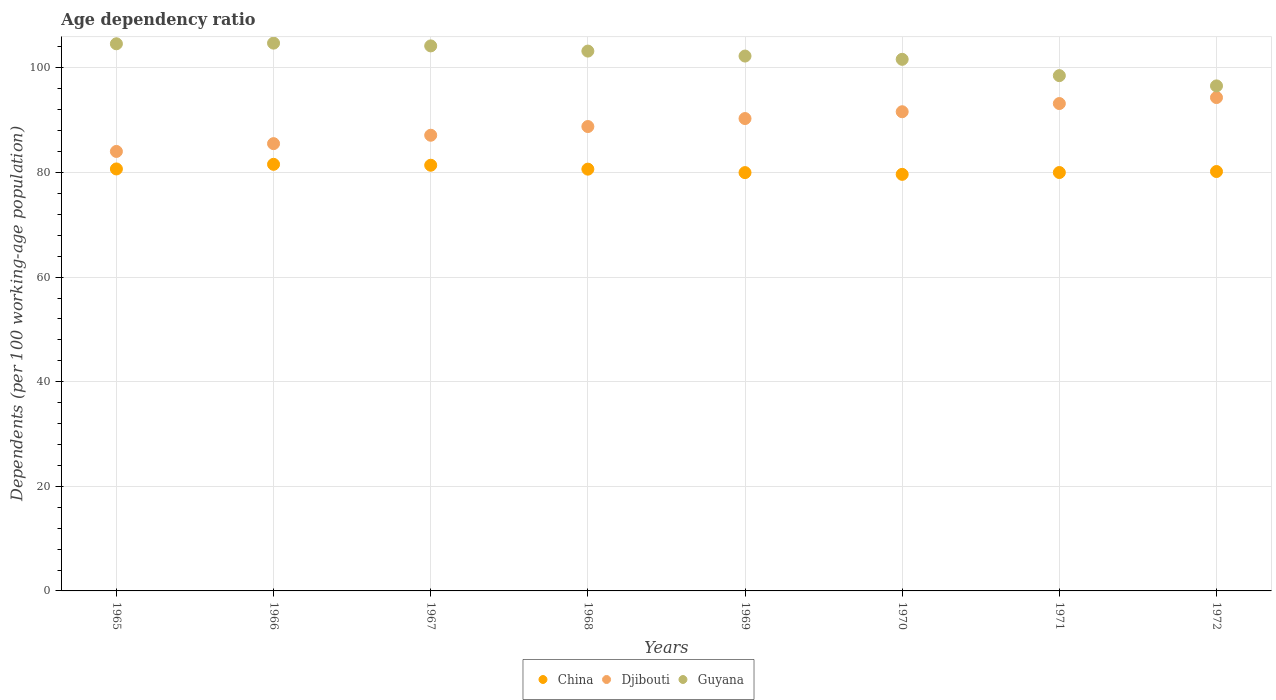What is the age dependency ratio in in Guyana in 1968?
Your answer should be compact. 103.22. Across all years, what is the maximum age dependency ratio in in Djibouti?
Keep it short and to the point. 94.33. Across all years, what is the minimum age dependency ratio in in Guyana?
Your answer should be compact. 96.56. In which year was the age dependency ratio in in Djibouti maximum?
Ensure brevity in your answer.  1972. In which year was the age dependency ratio in in Guyana minimum?
Provide a short and direct response. 1972. What is the total age dependency ratio in in China in the graph?
Your answer should be very brief. 644.09. What is the difference between the age dependency ratio in in Djibouti in 1967 and that in 1972?
Offer a terse response. -7.21. What is the difference between the age dependency ratio in in Guyana in 1967 and the age dependency ratio in in China in 1965?
Make the answer very short. 23.53. What is the average age dependency ratio in in China per year?
Provide a succinct answer. 80.51. In the year 1970, what is the difference between the age dependency ratio in in China and age dependency ratio in in Guyana?
Provide a succinct answer. -21.99. In how many years, is the age dependency ratio in in Djibouti greater than 96 %?
Offer a terse response. 0. What is the ratio of the age dependency ratio in in Djibouti in 1966 to that in 1972?
Offer a very short reply. 0.91. Is the age dependency ratio in in China in 1968 less than that in 1971?
Provide a succinct answer. No. Is the difference between the age dependency ratio in in China in 1969 and 1972 greater than the difference between the age dependency ratio in in Guyana in 1969 and 1972?
Ensure brevity in your answer.  No. What is the difference between the highest and the second highest age dependency ratio in in China?
Provide a short and direct response. 0.17. What is the difference between the highest and the lowest age dependency ratio in in Djibouti?
Keep it short and to the point. 10.3. In how many years, is the age dependency ratio in in China greater than the average age dependency ratio in in China taken over all years?
Your response must be concise. 4. Does the age dependency ratio in in China monotonically increase over the years?
Your answer should be very brief. No. How many dotlines are there?
Your response must be concise. 3. How many years are there in the graph?
Your response must be concise. 8. What is the difference between two consecutive major ticks on the Y-axis?
Your answer should be very brief. 20. What is the title of the graph?
Ensure brevity in your answer.  Age dependency ratio. Does "Venezuela" appear as one of the legend labels in the graph?
Make the answer very short. No. What is the label or title of the Y-axis?
Offer a very short reply. Dependents (per 100 working-age population). What is the Dependents (per 100 working-age population) in China in 1965?
Ensure brevity in your answer.  80.68. What is the Dependents (per 100 working-age population) of Djibouti in 1965?
Ensure brevity in your answer.  84.03. What is the Dependents (per 100 working-age population) of Guyana in 1965?
Offer a terse response. 104.61. What is the Dependents (per 100 working-age population) in China in 1966?
Provide a succinct answer. 81.57. What is the Dependents (per 100 working-age population) in Djibouti in 1966?
Keep it short and to the point. 85.52. What is the Dependents (per 100 working-age population) in Guyana in 1966?
Your response must be concise. 104.74. What is the Dependents (per 100 working-age population) of China in 1967?
Ensure brevity in your answer.  81.39. What is the Dependents (per 100 working-age population) in Djibouti in 1967?
Offer a terse response. 87.13. What is the Dependents (per 100 working-age population) in Guyana in 1967?
Provide a short and direct response. 104.21. What is the Dependents (per 100 working-age population) of China in 1968?
Give a very brief answer. 80.64. What is the Dependents (per 100 working-age population) of Djibouti in 1968?
Make the answer very short. 88.79. What is the Dependents (per 100 working-age population) of Guyana in 1968?
Provide a short and direct response. 103.22. What is the Dependents (per 100 working-age population) of China in 1969?
Your answer should be very brief. 79.98. What is the Dependents (per 100 working-age population) of Djibouti in 1969?
Your answer should be very brief. 90.32. What is the Dependents (per 100 working-age population) in Guyana in 1969?
Ensure brevity in your answer.  102.27. What is the Dependents (per 100 working-age population) in China in 1970?
Offer a very short reply. 79.65. What is the Dependents (per 100 working-age population) of Djibouti in 1970?
Your response must be concise. 91.62. What is the Dependents (per 100 working-age population) in Guyana in 1970?
Ensure brevity in your answer.  101.64. What is the Dependents (per 100 working-age population) of China in 1971?
Keep it short and to the point. 80. What is the Dependents (per 100 working-age population) in Djibouti in 1971?
Make the answer very short. 93.19. What is the Dependents (per 100 working-age population) of Guyana in 1971?
Your answer should be compact. 98.52. What is the Dependents (per 100 working-age population) of China in 1972?
Provide a succinct answer. 80.19. What is the Dependents (per 100 working-age population) of Djibouti in 1972?
Offer a terse response. 94.33. What is the Dependents (per 100 working-age population) in Guyana in 1972?
Provide a short and direct response. 96.56. Across all years, what is the maximum Dependents (per 100 working-age population) in China?
Offer a terse response. 81.57. Across all years, what is the maximum Dependents (per 100 working-age population) in Djibouti?
Your answer should be compact. 94.33. Across all years, what is the maximum Dependents (per 100 working-age population) of Guyana?
Offer a very short reply. 104.74. Across all years, what is the minimum Dependents (per 100 working-age population) of China?
Keep it short and to the point. 79.65. Across all years, what is the minimum Dependents (per 100 working-age population) in Djibouti?
Provide a short and direct response. 84.03. Across all years, what is the minimum Dependents (per 100 working-age population) of Guyana?
Offer a terse response. 96.56. What is the total Dependents (per 100 working-age population) in China in the graph?
Ensure brevity in your answer.  644.09. What is the total Dependents (per 100 working-age population) of Djibouti in the graph?
Offer a terse response. 714.92. What is the total Dependents (per 100 working-age population) of Guyana in the graph?
Your answer should be very brief. 815.76. What is the difference between the Dependents (per 100 working-age population) of China in 1965 and that in 1966?
Provide a short and direct response. -0.88. What is the difference between the Dependents (per 100 working-age population) in Djibouti in 1965 and that in 1966?
Your response must be concise. -1.49. What is the difference between the Dependents (per 100 working-age population) in Guyana in 1965 and that in 1966?
Keep it short and to the point. -0.12. What is the difference between the Dependents (per 100 working-age population) in China in 1965 and that in 1967?
Provide a short and direct response. -0.71. What is the difference between the Dependents (per 100 working-age population) in Djibouti in 1965 and that in 1967?
Keep it short and to the point. -3.1. What is the difference between the Dependents (per 100 working-age population) in Guyana in 1965 and that in 1967?
Keep it short and to the point. 0.41. What is the difference between the Dependents (per 100 working-age population) of China in 1965 and that in 1968?
Your answer should be compact. 0.04. What is the difference between the Dependents (per 100 working-age population) of Djibouti in 1965 and that in 1968?
Keep it short and to the point. -4.76. What is the difference between the Dependents (per 100 working-age population) in Guyana in 1965 and that in 1968?
Your answer should be compact. 1.4. What is the difference between the Dependents (per 100 working-age population) in China in 1965 and that in 1969?
Your answer should be very brief. 0.7. What is the difference between the Dependents (per 100 working-age population) of Djibouti in 1965 and that in 1969?
Your answer should be compact. -6.29. What is the difference between the Dependents (per 100 working-age population) of Guyana in 1965 and that in 1969?
Offer a terse response. 2.35. What is the difference between the Dependents (per 100 working-age population) of China in 1965 and that in 1970?
Provide a short and direct response. 1.03. What is the difference between the Dependents (per 100 working-age population) of Djibouti in 1965 and that in 1970?
Your answer should be very brief. -7.59. What is the difference between the Dependents (per 100 working-age population) in Guyana in 1965 and that in 1970?
Make the answer very short. 2.97. What is the difference between the Dependents (per 100 working-age population) of China in 1965 and that in 1971?
Give a very brief answer. 0.68. What is the difference between the Dependents (per 100 working-age population) of Djibouti in 1965 and that in 1971?
Keep it short and to the point. -9.16. What is the difference between the Dependents (per 100 working-age population) of Guyana in 1965 and that in 1971?
Your answer should be very brief. 6.09. What is the difference between the Dependents (per 100 working-age population) of China in 1965 and that in 1972?
Ensure brevity in your answer.  0.49. What is the difference between the Dependents (per 100 working-age population) of Djibouti in 1965 and that in 1972?
Ensure brevity in your answer.  -10.3. What is the difference between the Dependents (per 100 working-age population) of Guyana in 1965 and that in 1972?
Keep it short and to the point. 8.05. What is the difference between the Dependents (per 100 working-age population) of China in 1966 and that in 1967?
Offer a very short reply. 0.17. What is the difference between the Dependents (per 100 working-age population) in Djibouti in 1966 and that in 1967?
Your answer should be very brief. -1.61. What is the difference between the Dependents (per 100 working-age population) in Guyana in 1966 and that in 1967?
Keep it short and to the point. 0.53. What is the difference between the Dependents (per 100 working-age population) of China in 1966 and that in 1968?
Provide a succinct answer. 0.92. What is the difference between the Dependents (per 100 working-age population) of Djibouti in 1966 and that in 1968?
Make the answer very short. -3.27. What is the difference between the Dependents (per 100 working-age population) of Guyana in 1966 and that in 1968?
Provide a succinct answer. 1.52. What is the difference between the Dependents (per 100 working-age population) in China in 1966 and that in 1969?
Make the answer very short. 1.59. What is the difference between the Dependents (per 100 working-age population) in Djibouti in 1966 and that in 1969?
Your answer should be compact. -4.8. What is the difference between the Dependents (per 100 working-age population) of Guyana in 1966 and that in 1969?
Your answer should be very brief. 2.47. What is the difference between the Dependents (per 100 working-age population) in China in 1966 and that in 1970?
Provide a short and direct response. 1.92. What is the difference between the Dependents (per 100 working-age population) in Djibouti in 1966 and that in 1970?
Ensure brevity in your answer.  -6.1. What is the difference between the Dependents (per 100 working-age population) of Guyana in 1966 and that in 1970?
Provide a succinct answer. 3.09. What is the difference between the Dependents (per 100 working-age population) in China in 1966 and that in 1971?
Offer a very short reply. 1.57. What is the difference between the Dependents (per 100 working-age population) in Djibouti in 1966 and that in 1971?
Keep it short and to the point. -7.67. What is the difference between the Dependents (per 100 working-age population) in Guyana in 1966 and that in 1971?
Offer a terse response. 6.21. What is the difference between the Dependents (per 100 working-age population) of China in 1966 and that in 1972?
Provide a short and direct response. 1.38. What is the difference between the Dependents (per 100 working-age population) in Djibouti in 1966 and that in 1972?
Make the answer very short. -8.81. What is the difference between the Dependents (per 100 working-age population) in Guyana in 1966 and that in 1972?
Offer a terse response. 8.18. What is the difference between the Dependents (per 100 working-age population) of China in 1967 and that in 1968?
Offer a terse response. 0.75. What is the difference between the Dependents (per 100 working-age population) of Djibouti in 1967 and that in 1968?
Give a very brief answer. -1.66. What is the difference between the Dependents (per 100 working-age population) in China in 1967 and that in 1969?
Provide a short and direct response. 1.41. What is the difference between the Dependents (per 100 working-age population) of Djibouti in 1967 and that in 1969?
Your answer should be compact. -3.19. What is the difference between the Dependents (per 100 working-age population) of Guyana in 1967 and that in 1969?
Offer a very short reply. 1.94. What is the difference between the Dependents (per 100 working-age population) of China in 1967 and that in 1970?
Offer a very short reply. 1.74. What is the difference between the Dependents (per 100 working-age population) in Djibouti in 1967 and that in 1970?
Your response must be concise. -4.49. What is the difference between the Dependents (per 100 working-age population) of Guyana in 1967 and that in 1970?
Provide a succinct answer. 2.57. What is the difference between the Dependents (per 100 working-age population) in China in 1967 and that in 1971?
Offer a terse response. 1.39. What is the difference between the Dependents (per 100 working-age population) in Djibouti in 1967 and that in 1971?
Offer a terse response. -6.06. What is the difference between the Dependents (per 100 working-age population) of Guyana in 1967 and that in 1971?
Provide a succinct answer. 5.69. What is the difference between the Dependents (per 100 working-age population) in China in 1967 and that in 1972?
Give a very brief answer. 1.2. What is the difference between the Dependents (per 100 working-age population) of Djibouti in 1967 and that in 1972?
Your answer should be compact. -7.21. What is the difference between the Dependents (per 100 working-age population) in Guyana in 1967 and that in 1972?
Provide a short and direct response. 7.65. What is the difference between the Dependents (per 100 working-age population) of China in 1968 and that in 1969?
Offer a terse response. 0.66. What is the difference between the Dependents (per 100 working-age population) in Djibouti in 1968 and that in 1969?
Provide a short and direct response. -1.53. What is the difference between the Dependents (per 100 working-age population) in Guyana in 1968 and that in 1969?
Your response must be concise. 0.95. What is the difference between the Dependents (per 100 working-age population) of China in 1968 and that in 1970?
Provide a short and direct response. 0.99. What is the difference between the Dependents (per 100 working-age population) of Djibouti in 1968 and that in 1970?
Offer a very short reply. -2.83. What is the difference between the Dependents (per 100 working-age population) in Guyana in 1968 and that in 1970?
Provide a short and direct response. 1.57. What is the difference between the Dependents (per 100 working-age population) in China in 1968 and that in 1971?
Your answer should be compact. 0.64. What is the difference between the Dependents (per 100 working-age population) of Djibouti in 1968 and that in 1971?
Keep it short and to the point. -4.4. What is the difference between the Dependents (per 100 working-age population) of Guyana in 1968 and that in 1971?
Make the answer very short. 4.69. What is the difference between the Dependents (per 100 working-age population) of China in 1968 and that in 1972?
Your response must be concise. 0.45. What is the difference between the Dependents (per 100 working-age population) in Djibouti in 1968 and that in 1972?
Ensure brevity in your answer.  -5.54. What is the difference between the Dependents (per 100 working-age population) in Guyana in 1968 and that in 1972?
Your answer should be compact. 6.66. What is the difference between the Dependents (per 100 working-age population) in China in 1969 and that in 1970?
Make the answer very short. 0.33. What is the difference between the Dependents (per 100 working-age population) in Djibouti in 1969 and that in 1970?
Your answer should be very brief. -1.3. What is the difference between the Dependents (per 100 working-age population) in Guyana in 1969 and that in 1970?
Offer a very short reply. 0.62. What is the difference between the Dependents (per 100 working-age population) in China in 1969 and that in 1971?
Provide a short and direct response. -0.02. What is the difference between the Dependents (per 100 working-age population) in Djibouti in 1969 and that in 1971?
Your answer should be very brief. -2.87. What is the difference between the Dependents (per 100 working-age population) of Guyana in 1969 and that in 1971?
Offer a terse response. 3.74. What is the difference between the Dependents (per 100 working-age population) of China in 1969 and that in 1972?
Give a very brief answer. -0.21. What is the difference between the Dependents (per 100 working-age population) in Djibouti in 1969 and that in 1972?
Provide a short and direct response. -4.01. What is the difference between the Dependents (per 100 working-age population) of Guyana in 1969 and that in 1972?
Ensure brevity in your answer.  5.71. What is the difference between the Dependents (per 100 working-age population) in China in 1970 and that in 1971?
Offer a terse response. -0.35. What is the difference between the Dependents (per 100 working-age population) of Djibouti in 1970 and that in 1971?
Your answer should be compact. -1.57. What is the difference between the Dependents (per 100 working-age population) in Guyana in 1970 and that in 1971?
Give a very brief answer. 3.12. What is the difference between the Dependents (per 100 working-age population) in China in 1970 and that in 1972?
Provide a succinct answer. -0.54. What is the difference between the Dependents (per 100 working-age population) in Djibouti in 1970 and that in 1972?
Offer a very short reply. -2.71. What is the difference between the Dependents (per 100 working-age population) of Guyana in 1970 and that in 1972?
Provide a short and direct response. 5.08. What is the difference between the Dependents (per 100 working-age population) in China in 1971 and that in 1972?
Give a very brief answer. -0.19. What is the difference between the Dependents (per 100 working-age population) of Djibouti in 1971 and that in 1972?
Your answer should be very brief. -1.15. What is the difference between the Dependents (per 100 working-age population) in Guyana in 1971 and that in 1972?
Your response must be concise. 1.96. What is the difference between the Dependents (per 100 working-age population) of China in 1965 and the Dependents (per 100 working-age population) of Djibouti in 1966?
Ensure brevity in your answer.  -4.84. What is the difference between the Dependents (per 100 working-age population) in China in 1965 and the Dependents (per 100 working-age population) in Guyana in 1966?
Give a very brief answer. -24.05. What is the difference between the Dependents (per 100 working-age population) in Djibouti in 1965 and the Dependents (per 100 working-age population) in Guyana in 1966?
Your answer should be compact. -20.71. What is the difference between the Dependents (per 100 working-age population) of China in 1965 and the Dependents (per 100 working-age population) of Djibouti in 1967?
Your response must be concise. -6.44. What is the difference between the Dependents (per 100 working-age population) in China in 1965 and the Dependents (per 100 working-age population) in Guyana in 1967?
Keep it short and to the point. -23.53. What is the difference between the Dependents (per 100 working-age population) in Djibouti in 1965 and the Dependents (per 100 working-age population) in Guyana in 1967?
Ensure brevity in your answer.  -20.18. What is the difference between the Dependents (per 100 working-age population) of China in 1965 and the Dependents (per 100 working-age population) of Djibouti in 1968?
Your answer should be very brief. -8.11. What is the difference between the Dependents (per 100 working-age population) in China in 1965 and the Dependents (per 100 working-age population) in Guyana in 1968?
Give a very brief answer. -22.53. What is the difference between the Dependents (per 100 working-age population) in Djibouti in 1965 and the Dependents (per 100 working-age population) in Guyana in 1968?
Ensure brevity in your answer.  -19.19. What is the difference between the Dependents (per 100 working-age population) in China in 1965 and the Dependents (per 100 working-age population) in Djibouti in 1969?
Your answer should be compact. -9.64. What is the difference between the Dependents (per 100 working-age population) of China in 1965 and the Dependents (per 100 working-age population) of Guyana in 1969?
Offer a terse response. -21.58. What is the difference between the Dependents (per 100 working-age population) of Djibouti in 1965 and the Dependents (per 100 working-age population) of Guyana in 1969?
Your answer should be compact. -18.24. What is the difference between the Dependents (per 100 working-age population) in China in 1965 and the Dependents (per 100 working-age population) in Djibouti in 1970?
Ensure brevity in your answer.  -10.94. What is the difference between the Dependents (per 100 working-age population) of China in 1965 and the Dependents (per 100 working-age population) of Guyana in 1970?
Offer a very short reply. -20.96. What is the difference between the Dependents (per 100 working-age population) of Djibouti in 1965 and the Dependents (per 100 working-age population) of Guyana in 1970?
Provide a succinct answer. -17.61. What is the difference between the Dependents (per 100 working-age population) in China in 1965 and the Dependents (per 100 working-age population) in Djibouti in 1971?
Keep it short and to the point. -12.5. What is the difference between the Dependents (per 100 working-age population) of China in 1965 and the Dependents (per 100 working-age population) of Guyana in 1971?
Keep it short and to the point. -17.84. What is the difference between the Dependents (per 100 working-age population) of Djibouti in 1965 and the Dependents (per 100 working-age population) of Guyana in 1971?
Offer a very short reply. -14.49. What is the difference between the Dependents (per 100 working-age population) in China in 1965 and the Dependents (per 100 working-age population) in Djibouti in 1972?
Give a very brief answer. -13.65. What is the difference between the Dependents (per 100 working-age population) of China in 1965 and the Dependents (per 100 working-age population) of Guyana in 1972?
Offer a very short reply. -15.88. What is the difference between the Dependents (per 100 working-age population) of Djibouti in 1965 and the Dependents (per 100 working-age population) of Guyana in 1972?
Provide a succinct answer. -12.53. What is the difference between the Dependents (per 100 working-age population) in China in 1966 and the Dependents (per 100 working-age population) in Djibouti in 1967?
Ensure brevity in your answer.  -5.56. What is the difference between the Dependents (per 100 working-age population) in China in 1966 and the Dependents (per 100 working-age population) in Guyana in 1967?
Your answer should be very brief. -22.64. What is the difference between the Dependents (per 100 working-age population) in Djibouti in 1966 and the Dependents (per 100 working-age population) in Guyana in 1967?
Your answer should be compact. -18.69. What is the difference between the Dependents (per 100 working-age population) in China in 1966 and the Dependents (per 100 working-age population) in Djibouti in 1968?
Your response must be concise. -7.22. What is the difference between the Dependents (per 100 working-age population) in China in 1966 and the Dependents (per 100 working-age population) in Guyana in 1968?
Your answer should be compact. -21.65. What is the difference between the Dependents (per 100 working-age population) of Djibouti in 1966 and the Dependents (per 100 working-age population) of Guyana in 1968?
Ensure brevity in your answer.  -17.7. What is the difference between the Dependents (per 100 working-age population) in China in 1966 and the Dependents (per 100 working-age population) in Djibouti in 1969?
Keep it short and to the point. -8.75. What is the difference between the Dependents (per 100 working-age population) in China in 1966 and the Dependents (per 100 working-age population) in Guyana in 1969?
Your answer should be very brief. -20.7. What is the difference between the Dependents (per 100 working-age population) in Djibouti in 1966 and the Dependents (per 100 working-age population) in Guyana in 1969?
Give a very brief answer. -16.75. What is the difference between the Dependents (per 100 working-age population) of China in 1966 and the Dependents (per 100 working-age population) of Djibouti in 1970?
Give a very brief answer. -10.05. What is the difference between the Dependents (per 100 working-age population) in China in 1966 and the Dependents (per 100 working-age population) in Guyana in 1970?
Offer a very short reply. -20.08. What is the difference between the Dependents (per 100 working-age population) of Djibouti in 1966 and the Dependents (per 100 working-age population) of Guyana in 1970?
Offer a terse response. -16.12. What is the difference between the Dependents (per 100 working-age population) in China in 1966 and the Dependents (per 100 working-age population) in Djibouti in 1971?
Your response must be concise. -11.62. What is the difference between the Dependents (per 100 working-age population) in China in 1966 and the Dependents (per 100 working-age population) in Guyana in 1971?
Offer a very short reply. -16.96. What is the difference between the Dependents (per 100 working-age population) in Djibouti in 1966 and the Dependents (per 100 working-age population) in Guyana in 1971?
Your response must be concise. -13. What is the difference between the Dependents (per 100 working-age population) of China in 1966 and the Dependents (per 100 working-age population) of Djibouti in 1972?
Give a very brief answer. -12.77. What is the difference between the Dependents (per 100 working-age population) in China in 1966 and the Dependents (per 100 working-age population) in Guyana in 1972?
Your answer should be very brief. -15. What is the difference between the Dependents (per 100 working-age population) of Djibouti in 1966 and the Dependents (per 100 working-age population) of Guyana in 1972?
Your answer should be compact. -11.04. What is the difference between the Dependents (per 100 working-age population) of China in 1967 and the Dependents (per 100 working-age population) of Djibouti in 1968?
Make the answer very short. -7.4. What is the difference between the Dependents (per 100 working-age population) in China in 1967 and the Dependents (per 100 working-age population) in Guyana in 1968?
Offer a terse response. -21.83. What is the difference between the Dependents (per 100 working-age population) of Djibouti in 1967 and the Dependents (per 100 working-age population) of Guyana in 1968?
Give a very brief answer. -16.09. What is the difference between the Dependents (per 100 working-age population) in China in 1967 and the Dependents (per 100 working-age population) in Djibouti in 1969?
Your response must be concise. -8.93. What is the difference between the Dependents (per 100 working-age population) in China in 1967 and the Dependents (per 100 working-age population) in Guyana in 1969?
Offer a very short reply. -20.88. What is the difference between the Dependents (per 100 working-age population) in Djibouti in 1967 and the Dependents (per 100 working-age population) in Guyana in 1969?
Provide a short and direct response. -15.14. What is the difference between the Dependents (per 100 working-age population) in China in 1967 and the Dependents (per 100 working-age population) in Djibouti in 1970?
Provide a succinct answer. -10.23. What is the difference between the Dependents (per 100 working-age population) in China in 1967 and the Dependents (per 100 working-age population) in Guyana in 1970?
Make the answer very short. -20.25. What is the difference between the Dependents (per 100 working-age population) of Djibouti in 1967 and the Dependents (per 100 working-age population) of Guyana in 1970?
Offer a terse response. -14.52. What is the difference between the Dependents (per 100 working-age population) in China in 1967 and the Dependents (per 100 working-age population) in Djibouti in 1971?
Provide a short and direct response. -11.8. What is the difference between the Dependents (per 100 working-age population) of China in 1967 and the Dependents (per 100 working-age population) of Guyana in 1971?
Make the answer very short. -17.13. What is the difference between the Dependents (per 100 working-age population) in Djibouti in 1967 and the Dependents (per 100 working-age population) in Guyana in 1971?
Give a very brief answer. -11.4. What is the difference between the Dependents (per 100 working-age population) in China in 1967 and the Dependents (per 100 working-age population) in Djibouti in 1972?
Offer a terse response. -12.94. What is the difference between the Dependents (per 100 working-age population) in China in 1967 and the Dependents (per 100 working-age population) in Guyana in 1972?
Your response must be concise. -15.17. What is the difference between the Dependents (per 100 working-age population) in Djibouti in 1967 and the Dependents (per 100 working-age population) in Guyana in 1972?
Your answer should be very brief. -9.44. What is the difference between the Dependents (per 100 working-age population) in China in 1968 and the Dependents (per 100 working-age population) in Djibouti in 1969?
Give a very brief answer. -9.68. What is the difference between the Dependents (per 100 working-age population) of China in 1968 and the Dependents (per 100 working-age population) of Guyana in 1969?
Your answer should be compact. -21.62. What is the difference between the Dependents (per 100 working-age population) of Djibouti in 1968 and the Dependents (per 100 working-age population) of Guyana in 1969?
Offer a terse response. -13.48. What is the difference between the Dependents (per 100 working-age population) of China in 1968 and the Dependents (per 100 working-age population) of Djibouti in 1970?
Provide a succinct answer. -10.98. What is the difference between the Dependents (per 100 working-age population) of China in 1968 and the Dependents (per 100 working-age population) of Guyana in 1970?
Provide a short and direct response. -21. What is the difference between the Dependents (per 100 working-age population) of Djibouti in 1968 and the Dependents (per 100 working-age population) of Guyana in 1970?
Give a very brief answer. -12.85. What is the difference between the Dependents (per 100 working-age population) of China in 1968 and the Dependents (per 100 working-age population) of Djibouti in 1971?
Ensure brevity in your answer.  -12.54. What is the difference between the Dependents (per 100 working-age population) in China in 1968 and the Dependents (per 100 working-age population) in Guyana in 1971?
Your answer should be compact. -17.88. What is the difference between the Dependents (per 100 working-age population) of Djibouti in 1968 and the Dependents (per 100 working-age population) of Guyana in 1971?
Ensure brevity in your answer.  -9.73. What is the difference between the Dependents (per 100 working-age population) in China in 1968 and the Dependents (per 100 working-age population) in Djibouti in 1972?
Your response must be concise. -13.69. What is the difference between the Dependents (per 100 working-age population) in China in 1968 and the Dependents (per 100 working-age population) in Guyana in 1972?
Provide a short and direct response. -15.92. What is the difference between the Dependents (per 100 working-age population) of Djibouti in 1968 and the Dependents (per 100 working-age population) of Guyana in 1972?
Ensure brevity in your answer.  -7.77. What is the difference between the Dependents (per 100 working-age population) of China in 1969 and the Dependents (per 100 working-age population) of Djibouti in 1970?
Provide a succinct answer. -11.64. What is the difference between the Dependents (per 100 working-age population) of China in 1969 and the Dependents (per 100 working-age population) of Guyana in 1970?
Keep it short and to the point. -21.66. What is the difference between the Dependents (per 100 working-age population) in Djibouti in 1969 and the Dependents (per 100 working-age population) in Guyana in 1970?
Your answer should be very brief. -11.32. What is the difference between the Dependents (per 100 working-age population) of China in 1969 and the Dependents (per 100 working-age population) of Djibouti in 1971?
Your answer should be compact. -13.21. What is the difference between the Dependents (per 100 working-age population) of China in 1969 and the Dependents (per 100 working-age population) of Guyana in 1971?
Keep it short and to the point. -18.54. What is the difference between the Dependents (per 100 working-age population) in Djibouti in 1969 and the Dependents (per 100 working-age population) in Guyana in 1971?
Ensure brevity in your answer.  -8.2. What is the difference between the Dependents (per 100 working-age population) in China in 1969 and the Dependents (per 100 working-age population) in Djibouti in 1972?
Offer a very short reply. -14.35. What is the difference between the Dependents (per 100 working-age population) in China in 1969 and the Dependents (per 100 working-age population) in Guyana in 1972?
Keep it short and to the point. -16.58. What is the difference between the Dependents (per 100 working-age population) of Djibouti in 1969 and the Dependents (per 100 working-age population) of Guyana in 1972?
Your answer should be very brief. -6.24. What is the difference between the Dependents (per 100 working-age population) in China in 1970 and the Dependents (per 100 working-age population) in Djibouti in 1971?
Your answer should be very brief. -13.54. What is the difference between the Dependents (per 100 working-age population) of China in 1970 and the Dependents (per 100 working-age population) of Guyana in 1971?
Ensure brevity in your answer.  -18.87. What is the difference between the Dependents (per 100 working-age population) in Djibouti in 1970 and the Dependents (per 100 working-age population) in Guyana in 1971?
Make the answer very short. -6.9. What is the difference between the Dependents (per 100 working-age population) in China in 1970 and the Dependents (per 100 working-age population) in Djibouti in 1972?
Your answer should be compact. -14.68. What is the difference between the Dependents (per 100 working-age population) in China in 1970 and the Dependents (per 100 working-age population) in Guyana in 1972?
Make the answer very short. -16.91. What is the difference between the Dependents (per 100 working-age population) in Djibouti in 1970 and the Dependents (per 100 working-age population) in Guyana in 1972?
Your answer should be compact. -4.94. What is the difference between the Dependents (per 100 working-age population) of China in 1971 and the Dependents (per 100 working-age population) of Djibouti in 1972?
Keep it short and to the point. -14.33. What is the difference between the Dependents (per 100 working-age population) of China in 1971 and the Dependents (per 100 working-age population) of Guyana in 1972?
Keep it short and to the point. -16.56. What is the difference between the Dependents (per 100 working-age population) of Djibouti in 1971 and the Dependents (per 100 working-age population) of Guyana in 1972?
Your answer should be very brief. -3.37. What is the average Dependents (per 100 working-age population) of China per year?
Keep it short and to the point. 80.51. What is the average Dependents (per 100 working-age population) of Djibouti per year?
Offer a terse response. 89.36. What is the average Dependents (per 100 working-age population) in Guyana per year?
Provide a succinct answer. 101.97. In the year 1965, what is the difference between the Dependents (per 100 working-age population) of China and Dependents (per 100 working-age population) of Djibouti?
Provide a short and direct response. -3.35. In the year 1965, what is the difference between the Dependents (per 100 working-age population) in China and Dependents (per 100 working-age population) in Guyana?
Provide a short and direct response. -23.93. In the year 1965, what is the difference between the Dependents (per 100 working-age population) in Djibouti and Dependents (per 100 working-age population) in Guyana?
Ensure brevity in your answer.  -20.58. In the year 1966, what is the difference between the Dependents (per 100 working-age population) of China and Dependents (per 100 working-age population) of Djibouti?
Make the answer very short. -3.95. In the year 1966, what is the difference between the Dependents (per 100 working-age population) in China and Dependents (per 100 working-age population) in Guyana?
Make the answer very short. -23.17. In the year 1966, what is the difference between the Dependents (per 100 working-age population) in Djibouti and Dependents (per 100 working-age population) in Guyana?
Provide a short and direct response. -19.22. In the year 1967, what is the difference between the Dependents (per 100 working-age population) of China and Dependents (per 100 working-age population) of Djibouti?
Your response must be concise. -5.73. In the year 1967, what is the difference between the Dependents (per 100 working-age population) in China and Dependents (per 100 working-age population) in Guyana?
Your response must be concise. -22.82. In the year 1967, what is the difference between the Dependents (per 100 working-age population) in Djibouti and Dependents (per 100 working-age population) in Guyana?
Your answer should be very brief. -17.08. In the year 1968, what is the difference between the Dependents (per 100 working-age population) in China and Dependents (per 100 working-age population) in Djibouti?
Provide a short and direct response. -8.15. In the year 1968, what is the difference between the Dependents (per 100 working-age population) in China and Dependents (per 100 working-age population) in Guyana?
Your answer should be very brief. -22.57. In the year 1968, what is the difference between the Dependents (per 100 working-age population) of Djibouti and Dependents (per 100 working-age population) of Guyana?
Ensure brevity in your answer.  -14.43. In the year 1969, what is the difference between the Dependents (per 100 working-age population) in China and Dependents (per 100 working-age population) in Djibouti?
Provide a succinct answer. -10.34. In the year 1969, what is the difference between the Dependents (per 100 working-age population) of China and Dependents (per 100 working-age population) of Guyana?
Make the answer very short. -22.29. In the year 1969, what is the difference between the Dependents (per 100 working-age population) in Djibouti and Dependents (per 100 working-age population) in Guyana?
Your response must be concise. -11.95. In the year 1970, what is the difference between the Dependents (per 100 working-age population) of China and Dependents (per 100 working-age population) of Djibouti?
Give a very brief answer. -11.97. In the year 1970, what is the difference between the Dependents (per 100 working-age population) in China and Dependents (per 100 working-age population) in Guyana?
Your response must be concise. -21.99. In the year 1970, what is the difference between the Dependents (per 100 working-age population) in Djibouti and Dependents (per 100 working-age population) in Guyana?
Your answer should be very brief. -10.02. In the year 1971, what is the difference between the Dependents (per 100 working-age population) of China and Dependents (per 100 working-age population) of Djibouti?
Provide a succinct answer. -13.19. In the year 1971, what is the difference between the Dependents (per 100 working-age population) of China and Dependents (per 100 working-age population) of Guyana?
Offer a terse response. -18.52. In the year 1971, what is the difference between the Dependents (per 100 working-age population) of Djibouti and Dependents (per 100 working-age population) of Guyana?
Your answer should be very brief. -5.34. In the year 1972, what is the difference between the Dependents (per 100 working-age population) in China and Dependents (per 100 working-age population) in Djibouti?
Your response must be concise. -14.14. In the year 1972, what is the difference between the Dependents (per 100 working-age population) in China and Dependents (per 100 working-age population) in Guyana?
Provide a short and direct response. -16.37. In the year 1972, what is the difference between the Dependents (per 100 working-age population) in Djibouti and Dependents (per 100 working-age population) in Guyana?
Give a very brief answer. -2.23. What is the ratio of the Dependents (per 100 working-age population) in China in 1965 to that in 1966?
Provide a short and direct response. 0.99. What is the ratio of the Dependents (per 100 working-age population) of Djibouti in 1965 to that in 1966?
Provide a succinct answer. 0.98. What is the ratio of the Dependents (per 100 working-age population) of Guyana in 1965 to that in 1966?
Your answer should be compact. 1. What is the ratio of the Dependents (per 100 working-age population) in China in 1965 to that in 1967?
Keep it short and to the point. 0.99. What is the ratio of the Dependents (per 100 working-age population) of Djibouti in 1965 to that in 1967?
Provide a short and direct response. 0.96. What is the ratio of the Dependents (per 100 working-age population) in Guyana in 1965 to that in 1967?
Give a very brief answer. 1. What is the ratio of the Dependents (per 100 working-age population) of Djibouti in 1965 to that in 1968?
Keep it short and to the point. 0.95. What is the ratio of the Dependents (per 100 working-age population) of Guyana in 1965 to that in 1968?
Make the answer very short. 1.01. What is the ratio of the Dependents (per 100 working-age population) in China in 1965 to that in 1969?
Provide a short and direct response. 1.01. What is the ratio of the Dependents (per 100 working-age population) in Djibouti in 1965 to that in 1969?
Offer a very short reply. 0.93. What is the ratio of the Dependents (per 100 working-age population) of Guyana in 1965 to that in 1969?
Provide a short and direct response. 1.02. What is the ratio of the Dependents (per 100 working-age population) of Djibouti in 1965 to that in 1970?
Provide a short and direct response. 0.92. What is the ratio of the Dependents (per 100 working-age population) in Guyana in 1965 to that in 1970?
Your response must be concise. 1.03. What is the ratio of the Dependents (per 100 working-age population) of China in 1965 to that in 1971?
Your answer should be very brief. 1.01. What is the ratio of the Dependents (per 100 working-age population) in Djibouti in 1965 to that in 1971?
Offer a terse response. 0.9. What is the ratio of the Dependents (per 100 working-age population) in Guyana in 1965 to that in 1971?
Offer a very short reply. 1.06. What is the ratio of the Dependents (per 100 working-age population) in Djibouti in 1965 to that in 1972?
Give a very brief answer. 0.89. What is the ratio of the Dependents (per 100 working-age population) of Guyana in 1965 to that in 1972?
Make the answer very short. 1.08. What is the ratio of the Dependents (per 100 working-age population) of Djibouti in 1966 to that in 1967?
Provide a succinct answer. 0.98. What is the ratio of the Dependents (per 100 working-age population) in Guyana in 1966 to that in 1967?
Give a very brief answer. 1.01. What is the ratio of the Dependents (per 100 working-age population) in China in 1966 to that in 1968?
Offer a terse response. 1.01. What is the ratio of the Dependents (per 100 working-age population) in Djibouti in 1966 to that in 1968?
Offer a very short reply. 0.96. What is the ratio of the Dependents (per 100 working-age population) in Guyana in 1966 to that in 1968?
Ensure brevity in your answer.  1.01. What is the ratio of the Dependents (per 100 working-age population) in China in 1966 to that in 1969?
Give a very brief answer. 1.02. What is the ratio of the Dependents (per 100 working-age population) in Djibouti in 1966 to that in 1969?
Give a very brief answer. 0.95. What is the ratio of the Dependents (per 100 working-age population) in Guyana in 1966 to that in 1969?
Offer a very short reply. 1.02. What is the ratio of the Dependents (per 100 working-age population) in China in 1966 to that in 1970?
Give a very brief answer. 1.02. What is the ratio of the Dependents (per 100 working-age population) of Djibouti in 1966 to that in 1970?
Provide a short and direct response. 0.93. What is the ratio of the Dependents (per 100 working-age population) in Guyana in 1966 to that in 1970?
Your answer should be very brief. 1.03. What is the ratio of the Dependents (per 100 working-age population) of China in 1966 to that in 1971?
Your response must be concise. 1.02. What is the ratio of the Dependents (per 100 working-age population) of Djibouti in 1966 to that in 1971?
Offer a very short reply. 0.92. What is the ratio of the Dependents (per 100 working-age population) in Guyana in 1966 to that in 1971?
Make the answer very short. 1.06. What is the ratio of the Dependents (per 100 working-age population) in China in 1966 to that in 1972?
Your response must be concise. 1.02. What is the ratio of the Dependents (per 100 working-age population) of Djibouti in 1966 to that in 1972?
Ensure brevity in your answer.  0.91. What is the ratio of the Dependents (per 100 working-age population) of Guyana in 1966 to that in 1972?
Provide a short and direct response. 1.08. What is the ratio of the Dependents (per 100 working-age population) of China in 1967 to that in 1968?
Provide a succinct answer. 1.01. What is the ratio of the Dependents (per 100 working-age population) in Djibouti in 1967 to that in 1968?
Keep it short and to the point. 0.98. What is the ratio of the Dependents (per 100 working-age population) of Guyana in 1967 to that in 1968?
Ensure brevity in your answer.  1.01. What is the ratio of the Dependents (per 100 working-age population) in China in 1967 to that in 1969?
Give a very brief answer. 1.02. What is the ratio of the Dependents (per 100 working-age population) of Djibouti in 1967 to that in 1969?
Give a very brief answer. 0.96. What is the ratio of the Dependents (per 100 working-age population) in Guyana in 1967 to that in 1969?
Keep it short and to the point. 1.02. What is the ratio of the Dependents (per 100 working-age population) of China in 1967 to that in 1970?
Your response must be concise. 1.02. What is the ratio of the Dependents (per 100 working-age population) in Djibouti in 1967 to that in 1970?
Ensure brevity in your answer.  0.95. What is the ratio of the Dependents (per 100 working-age population) of Guyana in 1967 to that in 1970?
Your response must be concise. 1.03. What is the ratio of the Dependents (per 100 working-age population) of China in 1967 to that in 1971?
Offer a very short reply. 1.02. What is the ratio of the Dependents (per 100 working-age population) in Djibouti in 1967 to that in 1971?
Offer a very short reply. 0.94. What is the ratio of the Dependents (per 100 working-age population) of Guyana in 1967 to that in 1971?
Ensure brevity in your answer.  1.06. What is the ratio of the Dependents (per 100 working-age population) in Djibouti in 1967 to that in 1972?
Ensure brevity in your answer.  0.92. What is the ratio of the Dependents (per 100 working-age population) in Guyana in 1967 to that in 1972?
Your answer should be very brief. 1.08. What is the ratio of the Dependents (per 100 working-age population) in China in 1968 to that in 1969?
Make the answer very short. 1.01. What is the ratio of the Dependents (per 100 working-age population) of Djibouti in 1968 to that in 1969?
Make the answer very short. 0.98. What is the ratio of the Dependents (per 100 working-age population) in Guyana in 1968 to that in 1969?
Offer a very short reply. 1.01. What is the ratio of the Dependents (per 100 working-age population) of China in 1968 to that in 1970?
Give a very brief answer. 1.01. What is the ratio of the Dependents (per 100 working-age population) of Djibouti in 1968 to that in 1970?
Give a very brief answer. 0.97. What is the ratio of the Dependents (per 100 working-age population) in Guyana in 1968 to that in 1970?
Ensure brevity in your answer.  1.02. What is the ratio of the Dependents (per 100 working-age population) of Djibouti in 1968 to that in 1971?
Keep it short and to the point. 0.95. What is the ratio of the Dependents (per 100 working-age population) in Guyana in 1968 to that in 1971?
Ensure brevity in your answer.  1.05. What is the ratio of the Dependents (per 100 working-age population) in Djibouti in 1968 to that in 1972?
Your answer should be compact. 0.94. What is the ratio of the Dependents (per 100 working-age population) in Guyana in 1968 to that in 1972?
Provide a short and direct response. 1.07. What is the ratio of the Dependents (per 100 working-age population) of China in 1969 to that in 1970?
Your answer should be very brief. 1. What is the ratio of the Dependents (per 100 working-age population) in Djibouti in 1969 to that in 1970?
Your answer should be compact. 0.99. What is the ratio of the Dependents (per 100 working-age population) in Djibouti in 1969 to that in 1971?
Offer a very short reply. 0.97. What is the ratio of the Dependents (per 100 working-age population) in Guyana in 1969 to that in 1971?
Offer a terse response. 1.04. What is the ratio of the Dependents (per 100 working-age population) in Djibouti in 1969 to that in 1972?
Keep it short and to the point. 0.96. What is the ratio of the Dependents (per 100 working-age population) of Guyana in 1969 to that in 1972?
Provide a succinct answer. 1.06. What is the ratio of the Dependents (per 100 working-age population) in Djibouti in 1970 to that in 1971?
Your response must be concise. 0.98. What is the ratio of the Dependents (per 100 working-age population) of Guyana in 1970 to that in 1971?
Offer a very short reply. 1.03. What is the ratio of the Dependents (per 100 working-age population) in China in 1970 to that in 1972?
Ensure brevity in your answer.  0.99. What is the ratio of the Dependents (per 100 working-age population) of Djibouti in 1970 to that in 1972?
Offer a terse response. 0.97. What is the ratio of the Dependents (per 100 working-age population) in Guyana in 1970 to that in 1972?
Make the answer very short. 1.05. What is the ratio of the Dependents (per 100 working-age population) in China in 1971 to that in 1972?
Keep it short and to the point. 1. What is the ratio of the Dependents (per 100 working-age population) of Djibouti in 1971 to that in 1972?
Keep it short and to the point. 0.99. What is the ratio of the Dependents (per 100 working-age population) of Guyana in 1971 to that in 1972?
Your response must be concise. 1.02. What is the difference between the highest and the second highest Dependents (per 100 working-age population) in China?
Make the answer very short. 0.17. What is the difference between the highest and the second highest Dependents (per 100 working-age population) in Djibouti?
Ensure brevity in your answer.  1.15. What is the difference between the highest and the second highest Dependents (per 100 working-age population) of Guyana?
Keep it short and to the point. 0.12. What is the difference between the highest and the lowest Dependents (per 100 working-age population) in China?
Your answer should be compact. 1.92. What is the difference between the highest and the lowest Dependents (per 100 working-age population) of Djibouti?
Your answer should be compact. 10.3. What is the difference between the highest and the lowest Dependents (per 100 working-age population) in Guyana?
Offer a terse response. 8.18. 